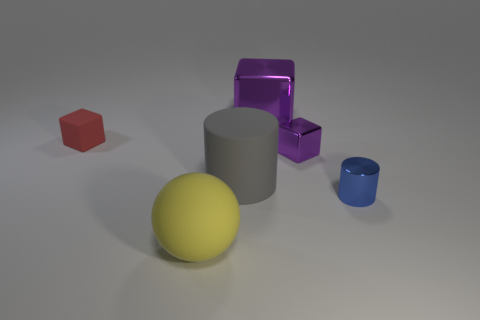Are there any other things that are the same material as the red cube?
Give a very brief answer. Yes. What material is the object that is both to the left of the big purple thing and behind the big gray rubber object?
Offer a very short reply. Rubber. There is a object behind the red object; is it the same size as the red cube?
Keep it short and to the point. No. What is the shape of the tiny purple metal object?
Your answer should be very brief. Cube. How many other big rubber objects have the same shape as the big gray rubber thing?
Your response must be concise. 0. What number of things are both behind the small purple metallic thing and to the right of the red cube?
Ensure brevity in your answer.  1. The shiny cylinder is what color?
Offer a terse response. Blue. Are there any tiny blue objects that have the same material as the blue cylinder?
Your answer should be very brief. No. Are there any small red rubber cubes that are behind the cylinder that is right of the purple thing behind the red rubber cube?
Your response must be concise. Yes. Are there any tiny red rubber things to the right of the tiny blue shiny thing?
Make the answer very short. No. 